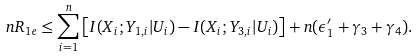Convert formula to latex. <formula><loc_0><loc_0><loc_500><loc_500>n R _ { 1 e } \leq \sum _ { i = 1 } ^ { n } \left [ I ( X _ { i } ; Y _ { 1 , i } | U _ { i } ) - I ( X _ { i } ; Y _ { 3 , i } | U _ { i } ) \right ] + n ( \epsilon ^ { \prime } _ { 1 } + \gamma _ { 3 } + \gamma _ { 4 } ) .</formula> 